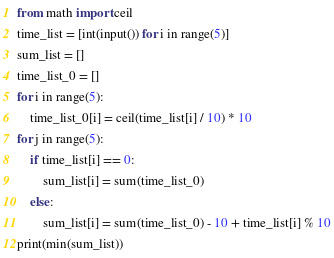<code> <loc_0><loc_0><loc_500><loc_500><_Python_>from math import ceil
time_list = [int(input()) for i in range(5)]
sum_list = []
time_list_0 = []
for i in range(5):
    time_list_0[i] = ceil(time_list[i] / 10) * 10
for j in range(5):
    if time_list[i] == 0:
        sum_list[i] = sum(time_list_0)
    else:
        sum_list[i] = sum(time_list_0) - 10 + time_list[i] % 10
print(min(sum_list))
</code> 